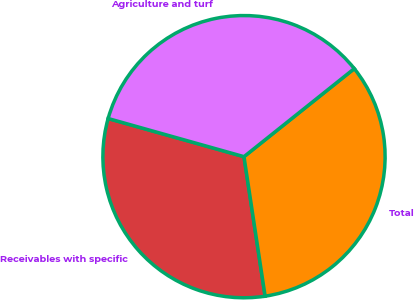Convert chart. <chart><loc_0><loc_0><loc_500><loc_500><pie_chart><fcel>Receivables with specific<fcel>Total<fcel>Agriculture and turf<nl><fcel>31.75%<fcel>33.33%<fcel>34.92%<nl></chart> 